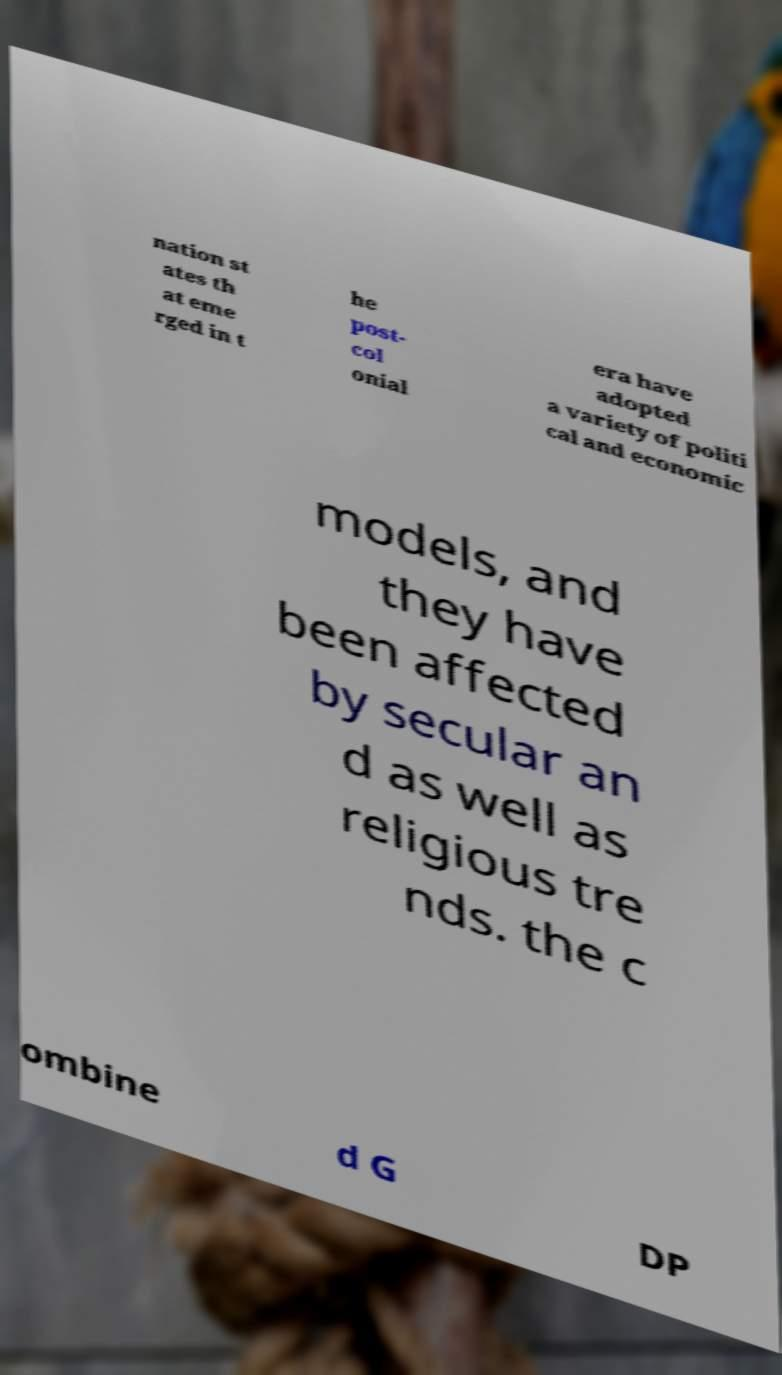Could you assist in decoding the text presented in this image and type it out clearly? nation st ates th at eme rged in t he post- col onial era have adopted a variety of politi cal and economic models, and they have been affected by secular an d as well as religious tre nds. the c ombine d G DP 